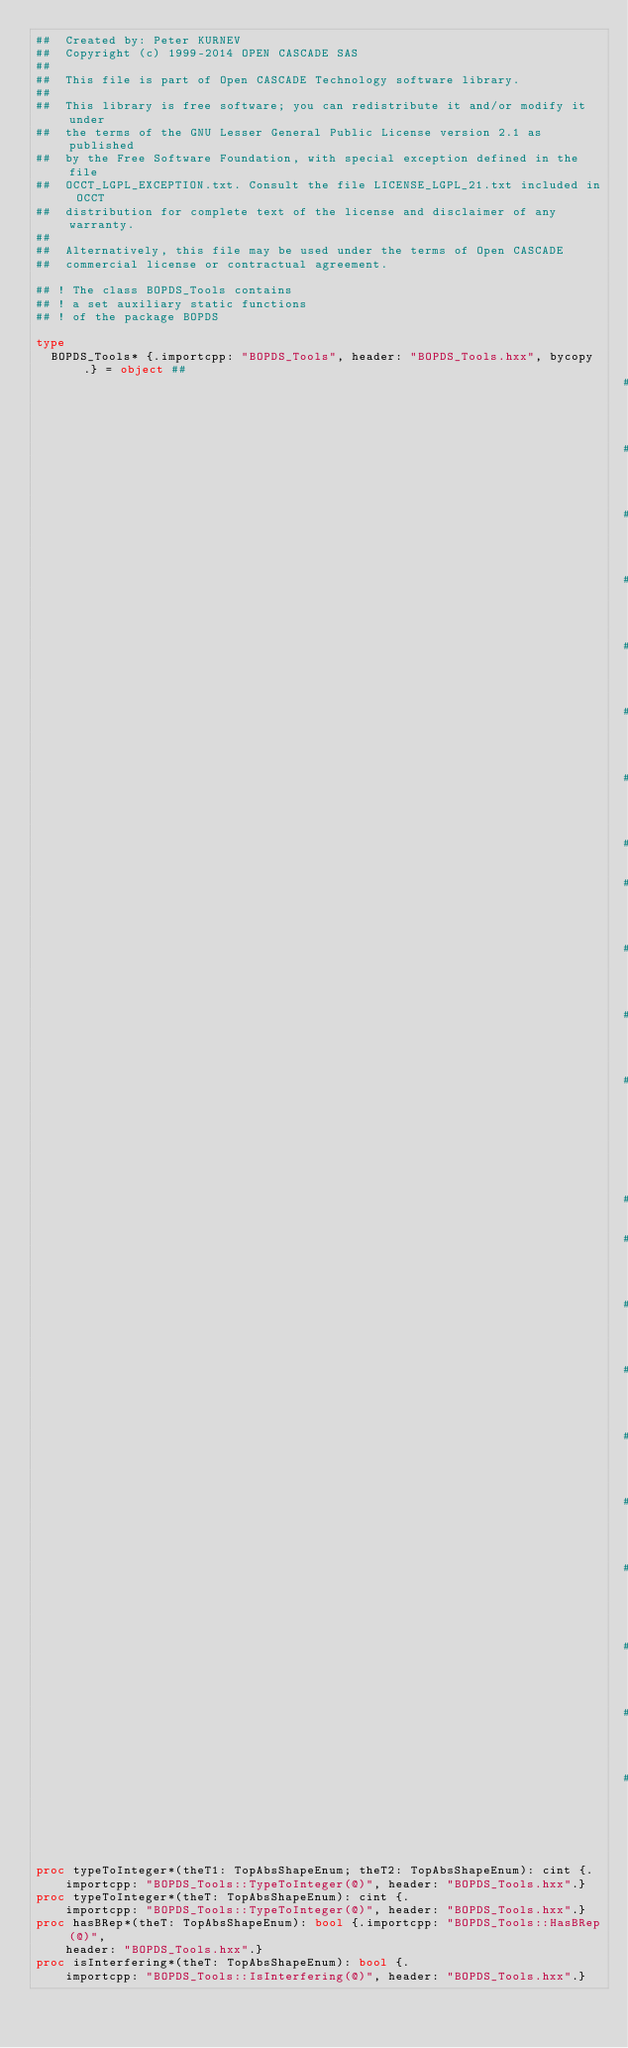Convert code to text. <code><loc_0><loc_0><loc_500><loc_500><_Nim_>##  Created by: Peter KURNEV
##  Copyright (c) 1999-2014 OPEN CASCADE SAS
##
##  This file is part of Open CASCADE Technology software library.
##
##  This library is free software; you can redistribute it and/or modify it under
##  the terms of the GNU Lesser General Public License version 2.1 as published
##  by the Free Software Foundation, with special exception defined in the file
##  OCCT_LGPL_EXCEPTION.txt. Consult the file LICENSE_LGPL_21.txt included in OCCT
##  distribution for complete text of the license and disclaimer of any warranty.
##
##  Alternatively, this file may be used under the terms of Open CASCADE
##  commercial license or contractual agreement.

## ! The class BOPDS_Tools contains
## ! a set auxiliary static functions
## ! of the package BOPDS

type
  BOPDS_Tools* {.importcpp: "BOPDS_Tools", header: "BOPDS_Tools.hxx", bycopy.} = object ##
                                                                                ## !
                                                                                ## Converts
                                                                                ## the
                                                                                ## conmbination
                                                                                ## of
                                                                                ## two
                                                                                ## types
                                                                                ##
                                                                                ## !
                                                                                ## of
                                                                                ## shape
                                                                                ## <theT1>,<theT2>
                                                                                ##
                                                                                ## !
                                                                                ## to
                                                                                ## the
                                                                                ## one
                                                                                ## integer
                                                                                ## value,
                                                                                ## that
                                                                                ## is
                                                                                ## returned


proc typeToInteger*(theT1: TopAbsShapeEnum; theT2: TopAbsShapeEnum): cint {.
    importcpp: "BOPDS_Tools::TypeToInteger(@)", header: "BOPDS_Tools.hxx".}
proc typeToInteger*(theT: TopAbsShapeEnum): cint {.
    importcpp: "BOPDS_Tools::TypeToInteger(@)", header: "BOPDS_Tools.hxx".}
proc hasBRep*(theT: TopAbsShapeEnum): bool {.importcpp: "BOPDS_Tools::HasBRep(@)",
    header: "BOPDS_Tools.hxx".}
proc isInterfering*(theT: TopAbsShapeEnum): bool {.
    importcpp: "BOPDS_Tools::IsInterfering(@)", header: "BOPDS_Tools.hxx".}

























</code> 